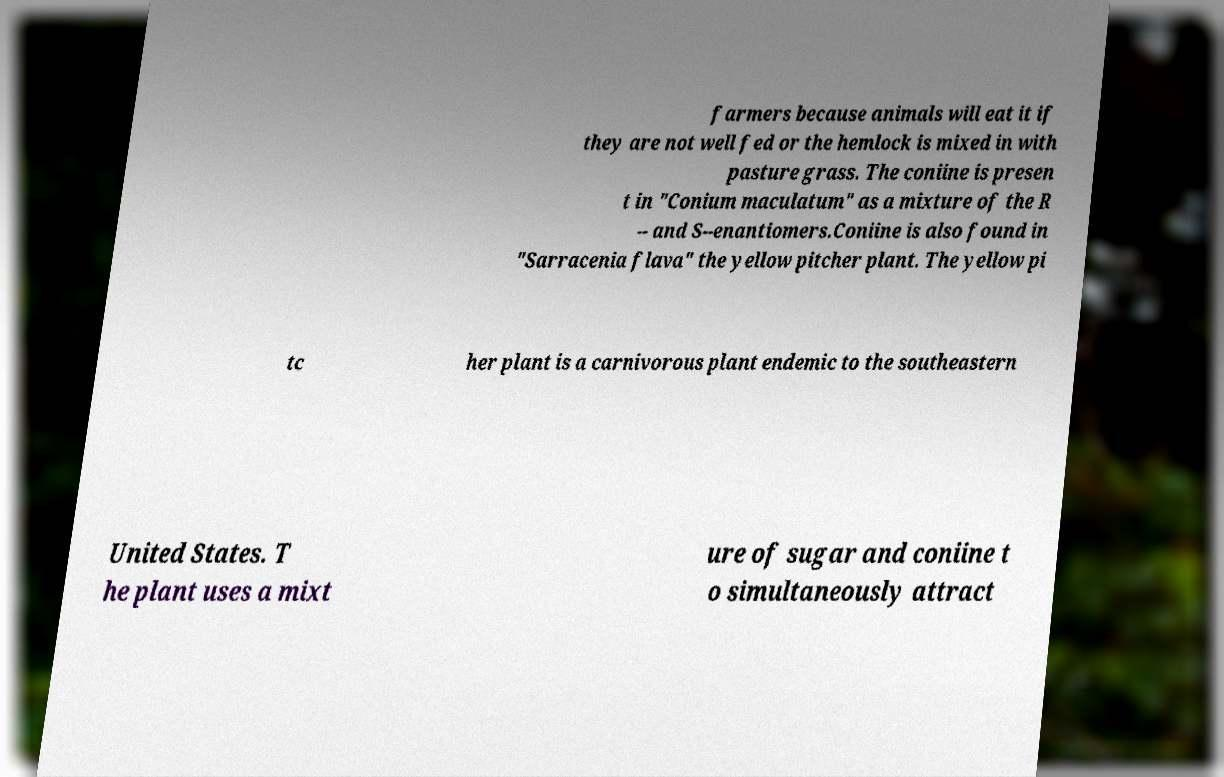There's text embedded in this image that I need extracted. Can you transcribe it verbatim? farmers because animals will eat it if they are not well fed or the hemlock is mixed in with pasture grass. The coniine is presen t in "Conium maculatum" as a mixture of the R -- and S--enantiomers.Coniine is also found in "Sarracenia flava" the yellow pitcher plant. The yellow pi tc her plant is a carnivorous plant endemic to the southeastern United States. T he plant uses a mixt ure of sugar and coniine t o simultaneously attract 